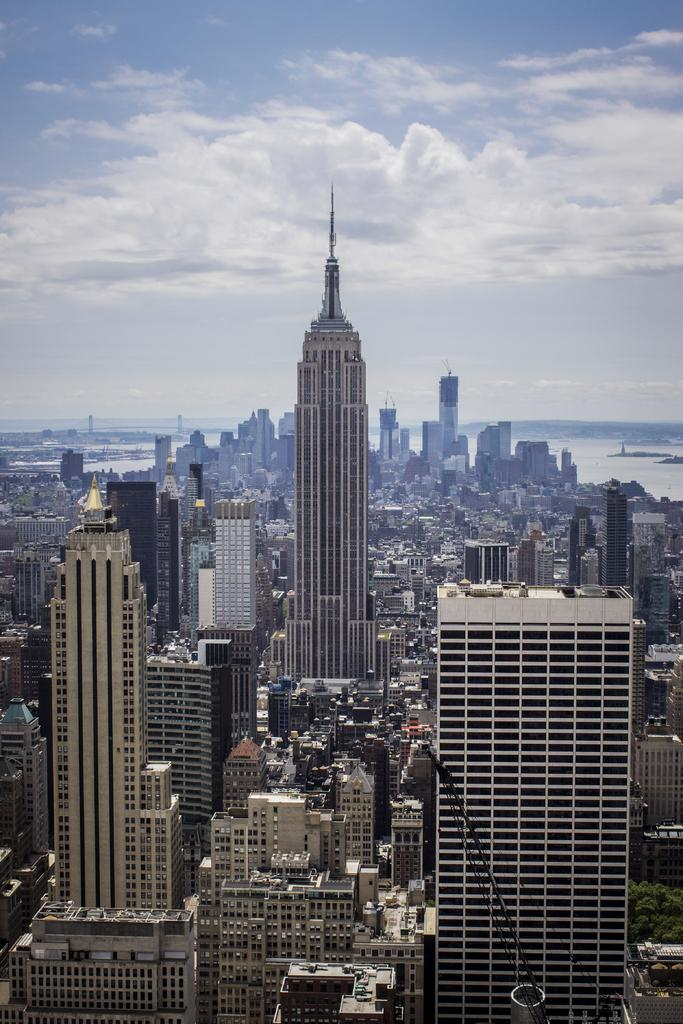What type of view is shown in the image? The image is an aerial view of a city. What kind of structures can be seen in the city? There are skyscrapers and other buildings in the image. What can be seen in the background of the image? There is water visible in the background of the image. How would you describe the sky in the image? The sky is partly cloudy, and the weather is sunny. Can you see anyone driving a car in the image? There are no cars or people visible in the image, so it is not possible to see anyone driving. Are there any pears visible in the image? There are no pears present in the image. 